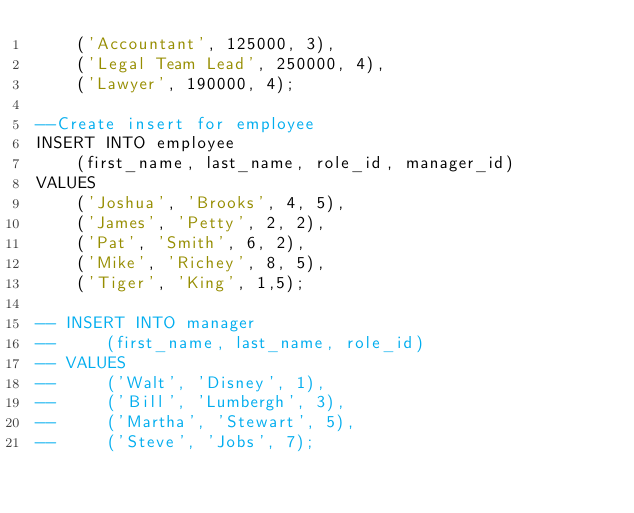Convert code to text. <code><loc_0><loc_0><loc_500><loc_500><_SQL_>    ('Accountant', 125000, 3),
    ('Legal Team Lead', 250000, 4),
    ('Lawyer', 190000, 4);

--Create insert for employee
INSERT INTO employee
    (first_name, last_name, role_id, manager_id)
VALUES
    ('Joshua', 'Brooks', 4, 5),
    ('James', 'Petty', 2, 2),
    ('Pat', 'Smith', 6, 2),
    ('Mike', 'Richey', 8, 5),
    ('Tiger', 'King', 1,5);
    
-- INSERT INTO manager
--     (first_name, last_name, role_id)
-- VALUES
--     ('Walt', 'Disney', 1),
--     ('Bill', 'Lumbergh', 3),
--     ('Martha', 'Stewart', 5),
--     ('Steve', 'Jobs', 7);
</code> 